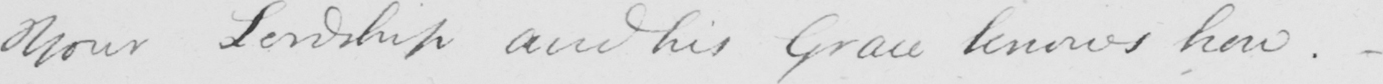Please provide the text content of this handwritten line. Your Lordship and his Grace knows how.- 